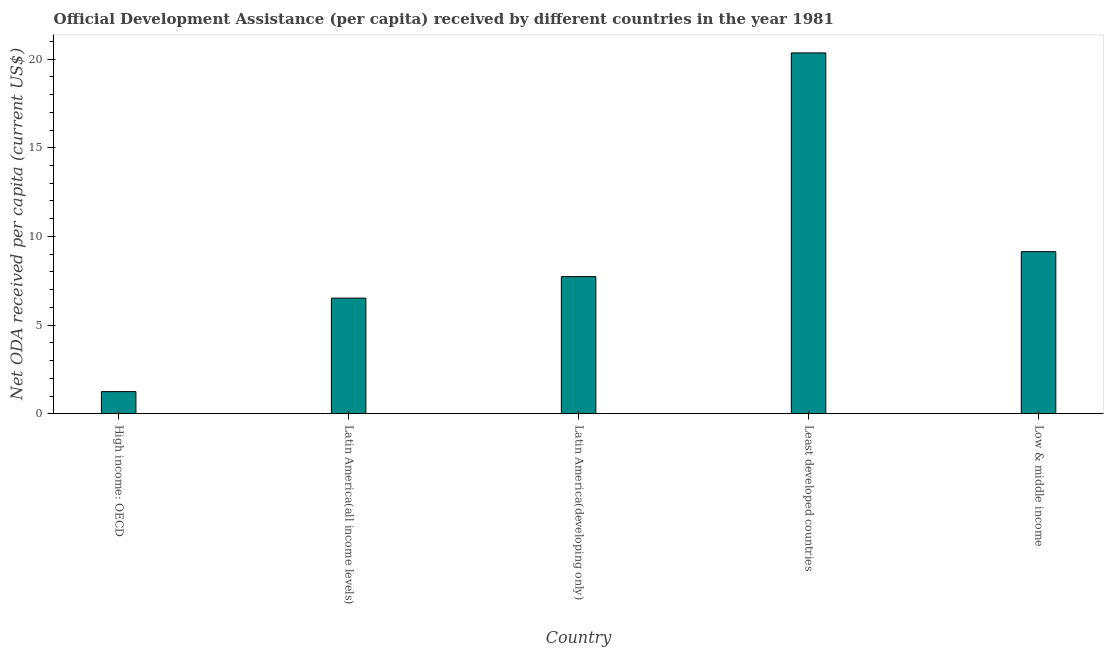Does the graph contain any zero values?
Keep it short and to the point. No. Does the graph contain grids?
Offer a very short reply. No. What is the title of the graph?
Offer a very short reply. Official Development Assistance (per capita) received by different countries in the year 1981. What is the label or title of the X-axis?
Provide a succinct answer. Country. What is the label or title of the Y-axis?
Provide a short and direct response. Net ODA received per capita (current US$). What is the net oda received per capita in Least developed countries?
Your response must be concise. 20.35. Across all countries, what is the maximum net oda received per capita?
Your answer should be compact. 20.35. Across all countries, what is the minimum net oda received per capita?
Provide a short and direct response. 1.25. In which country was the net oda received per capita maximum?
Give a very brief answer. Least developed countries. In which country was the net oda received per capita minimum?
Offer a very short reply. High income: OECD. What is the sum of the net oda received per capita?
Keep it short and to the point. 44.99. What is the difference between the net oda received per capita in Least developed countries and Low & middle income?
Provide a succinct answer. 11.21. What is the average net oda received per capita per country?
Your answer should be very brief. 9. What is the median net oda received per capita?
Offer a very short reply. 7.73. In how many countries, is the net oda received per capita greater than 9 US$?
Your answer should be compact. 2. What is the ratio of the net oda received per capita in Latin America(developing only) to that in Least developed countries?
Make the answer very short. 0.38. Is the net oda received per capita in Latin America(all income levels) less than that in Least developed countries?
Provide a short and direct response. Yes. Is the difference between the net oda received per capita in Least developed countries and Low & middle income greater than the difference between any two countries?
Provide a short and direct response. No. What is the difference between the highest and the second highest net oda received per capita?
Give a very brief answer. 11.21. Is the sum of the net oda received per capita in High income: OECD and Least developed countries greater than the maximum net oda received per capita across all countries?
Offer a very short reply. Yes. In how many countries, is the net oda received per capita greater than the average net oda received per capita taken over all countries?
Ensure brevity in your answer.  2. Are all the bars in the graph horizontal?
Give a very brief answer. No. What is the difference between two consecutive major ticks on the Y-axis?
Offer a terse response. 5. What is the Net ODA received per capita (current US$) of High income: OECD?
Your answer should be very brief. 1.25. What is the Net ODA received per capita (current US$) of Latin America(all income levels)?
Give a very brief answer. 6.52. What is the Net ODA received per capita (current US$) in Latin America(developing only)?
Your answer should be very brief. 7.73. What is the Net ODA received per capita (current US$) in Least developed countries?
Provide a succinct answer. 20.35. What is the Net ODA received per capita (current US$) of Low & middle income?
Make the answer very short. 9.14. What is the difference between the Net ODA received per capita (current US$) in High income: OECD and Latin America(all income levels)?
Give a very brief answer. -5.27. What is the difference between the Net ODA received per capita (current US$) in High income: OECD and Latin America(developing only)?
Give a very brief answer. -6.49. What is the difference between the Net ODA received per capita (current US$) in High income: OECD and Least developed countries?
Provide a short and direct response. -19.1. What is the difference between the Net ODA received per capita (current US$) in High income: OECD and Low & middle income?
Make the answer very short. -7.89. What is the difference between the Net ODA received per capita (current US$) in Latin America(all income levels) and Latin America(developing only)?
Provide a short and direct response. -1.21. What is the difference between the Net ODA received per capita (current US$) in Latin America(all income levels) and Least developed countries?
Give a very brief answer. -13.83. What is the difference between the Net ODA received per capita (current US$) in Latin America(all income levels) and Low & middle income?
Your answer should be compact. -2.62. What is the difference between the Net ODA received per capita (current US$) in Latin America(developing only) and Least developed countries?
Make the answer very short. -12.62. What is the difference between the Net ODA received per capita (current US$) in Latin America(developing only) and Low & middle income?
Provide a short and direct response. -1.41. What is the difference between the Net ODA received per capita (current US$) in Least developed countries and Low & middle income?
Your answer should be very brief. 11.21. What is the ratio of the Net ODA received per capita (current US$) in High income: OECD to that in Latin America(all income levels)?
Keep it short and to the point. 0.19. What is the ratio of the Net ODA received per capita (current US$) in High income: OECD to that in Latin America(developing only)?
Keep it short and to the point. 0.16. What is the ratio of the Net ODA received per capita (current US$) in High income: OECD to that in Least developed countries?
Keep it short and to the point. 0.06. What is the ratio of the Net ODA received per capita (current US$) in High income: OECD to that in Low & middle income?
Your response must be concise. 0.14. What is the ratio of the Net ODA received per capita (current US$) in Latin America(all income levels) to that in Latin America(developing only)?
Offer a terse response. 0.84. What is the ratio of the Net ODA received per capita (current US$) in Latin America(all income levels) to that in Least developed countries?
Provide a succinct answer. 0.32. What is the ratio of the Net ODA received per capita (current US$) in Latin America(all income levels) to that in Low & middle income?
Make the answer very short. 0.71. What is the ratio of the Net ODA received per capita (current US$) in Latin America(developing only) to that in Least developed countries?
Offer a very short reply. 0.38. What is the ratio of the Net ODA received per capita (current US$) in Latin America(developing only) to that in Low & middle income?
Provide a short and direct response. 0.85. What is the ratio of the Net ODA received per capita (current US$) in Least developed countries to that in Low & middle income?
Your answer should be compact. 2.23. 